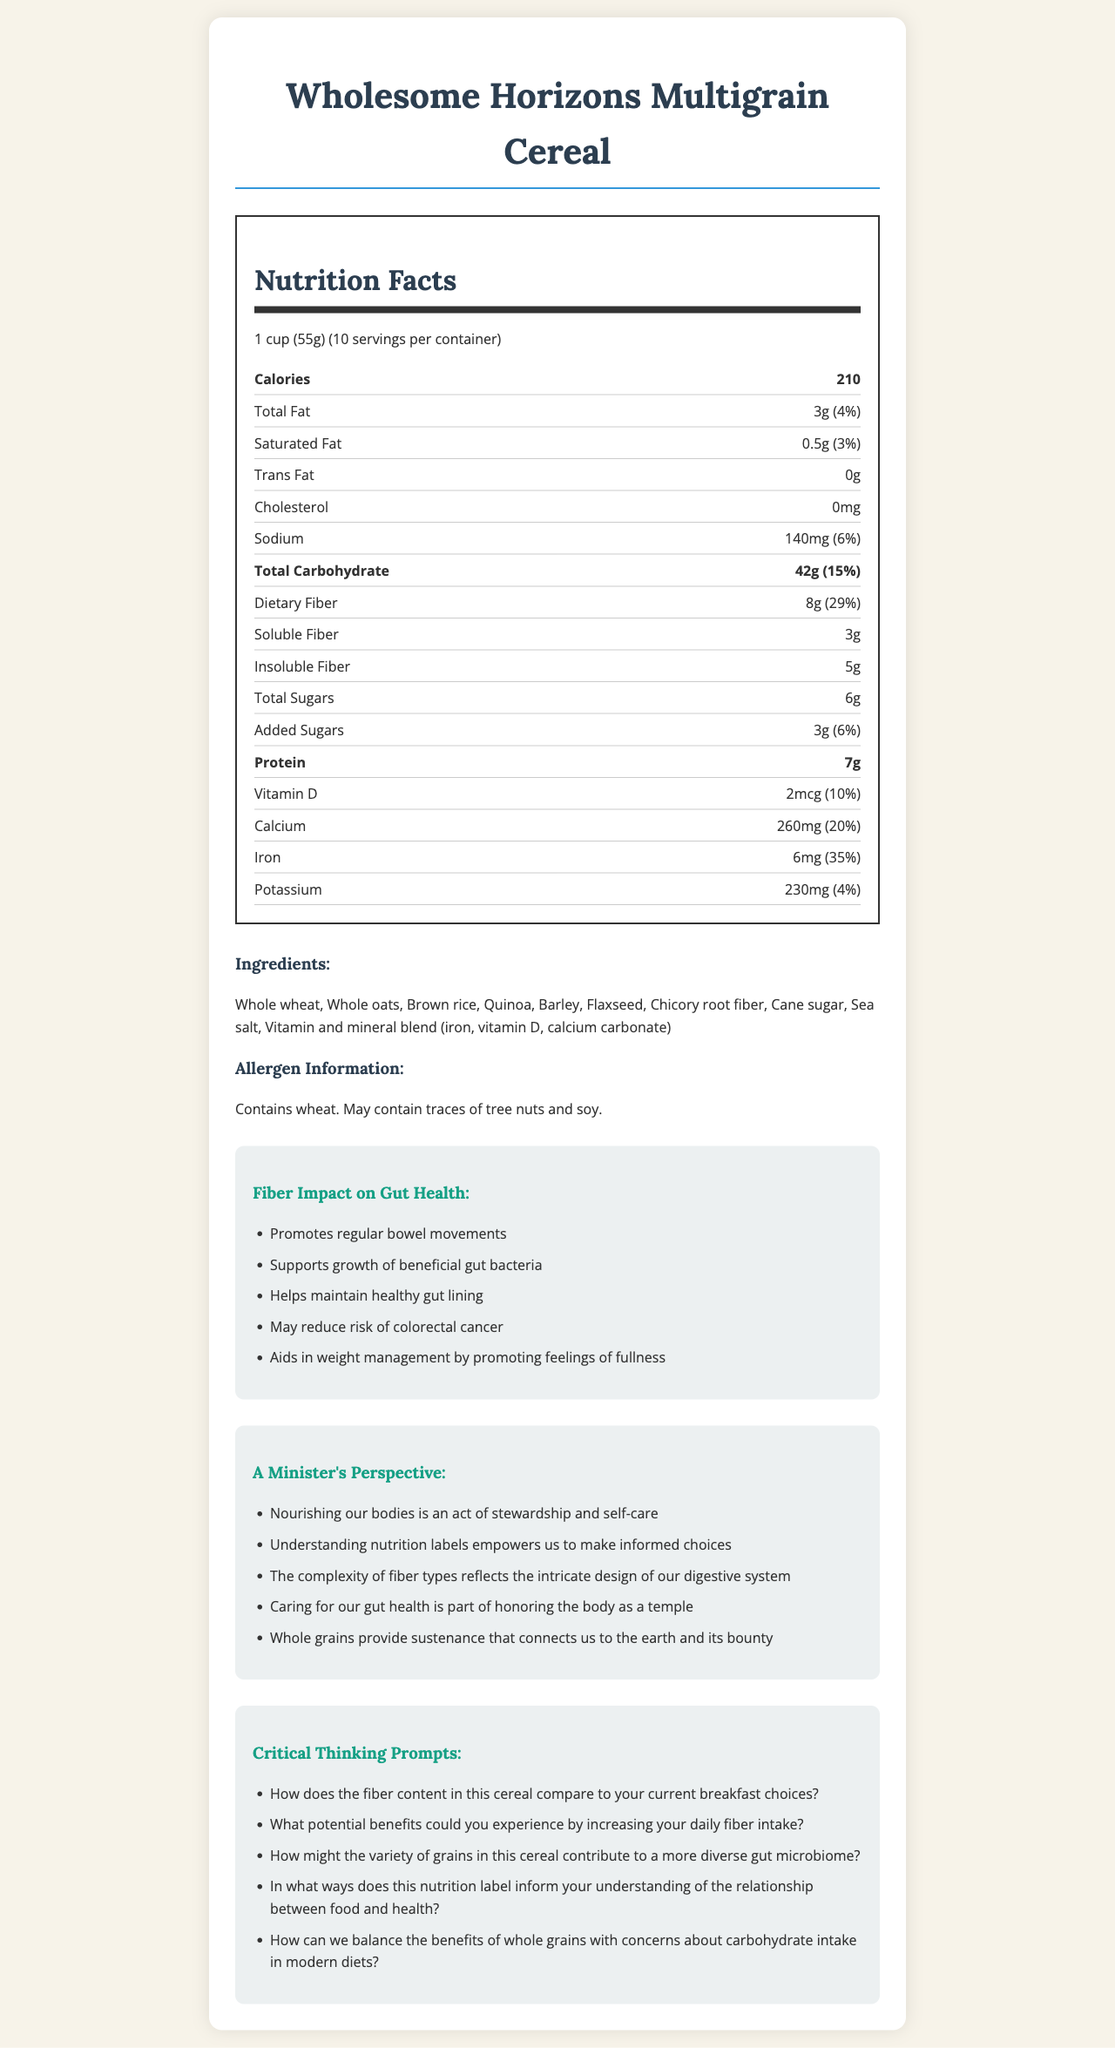How many grams of insoluble fiber are in one serving of Wholesome Horizons Multigrain Cereal? The nutrition label indicates that each serving contains 8g of dietary fiber, with a breakdown showing 5g of insoluble fiber.
Answer: 5g How might the variety of grains in this cereal contribute to a more diverse gut microbiome? The inclusion of different grains like whole wheat, oats, brown rice, quinoa, barley, and flaxseed offers a variety of nutrients and fibers that support various beneficial gut bacteria, contributing to a more diverse gut microbiome.
Answer: By providing a range of nutrients What is the percentage of the daily value for iron in one serving? The nutrition label states that one serving of the cereal provides 6mg of iron, which is 35% of the daily value.
Answer: 35% What potential benefits could you experience by increasing your daily fiber intake? The provided information lists several benefits of fiber, such as promoting regular bowel movements, supporting beneficial gut bacteria, maintaining a healthy gut lining, reducing the risk of colorectal cancer, and aiding in weight management.
Answer: Improved bowel movements, gut health, weight management What is the total amount of sugars, including added sugars, per serving? The nutrition label states that each serving contains 6g of total sugars, which includes 3g of added sugars.
Answer: 6g Which ingredient in the cereal specifically supports gut health through its fiber content? Chicory root fiber is known for its prebiotic properties, supporting the growth of beneficial gut bacteria.
Answer: Chicory root fiber How does the fiber content in this cereal compare to your current breakfast choices? This question requires the individual to reflect on their current breakfast choices and their fiber content, which cannot be determined from the document alone.
Answer: Varies by individual What are some of the benefits of soluble fiber highlighted in the document? Soluble fiber helps support the growth of beneficial gut bacteria and may promote feelings of fullness, aiding in weight management.
Answer: Supports gut health, promotes fullness What is the serving size for Wholesome Horizons Multigrain Cereal? The nutrition label lists the serving size as 1 cup, which is equivalent to 55 grams.
Answer: 1 cup (55g) True or False: This cereal contains no trans fat. The nutrition label explicitly states that there is 0g of trans fat per serving.
Answer: True How can we balance the benefits of whole grains with concerns about carbohydrate intake in modern diets? The document highlights the benefits of whole grains while acknowledging the importance of moderate carbohydrate intake. Choosing nutrient-dense whole grains can help balance these concerns.
Answer: By moderating intake and choosing nutrient-dense options Which of the following is an allergen listed for this cereal? A. Soy B. Wheat C. Nuts The allergen information clearly states that the cereal contains wheat and may contain traces of tree nuts and soy. Thus, Wheat is a certain allergen.
Answer: B Could you identify the total protein content in a serving of this cereal? The nutrition label states that there are 7 grams of protein per serving.
Answer: 7g What is one of the benefits mentioned about dietary fiber in relation to cancer? The document states that dietary fiber may reduce the risk of colorectal cancer, among other benefits.
Answer: May reduce the risk of colorectal cancer Summarize the main idea of the document. The summary captures the essence of the document, detailing the comprehensive nutrition profile, the impact on health, and the minister's encouragement of thoughtful consumption.
Answer: The document provides detailed nutrition information about Wholesome Horizons Multigrain Cereal, highlighting its ingredients, fiber content, and benefits for gut health. It includes a minister's perspective on the importance of nutrition and critical thinking prompts to encourage a deeper understanding of the relationship between food and health. How much calcium is in one serving of the cereal, and what percentage of the daily value does it represent? The nutrition label indicates that one serving contains 260mg of calcium, which is 20% of the daily value.
Answer: 260mg, 20% Is the exact amount of Vitamin D in this cereal sufficient for daily intake recommendations? The document states the amount of Vitamin D as 2mcg (10% DV), but whether this is sufficient for daily intake recommendations cannot be determined without knowing the individual's dietary needs.
Answer: Not enough information 